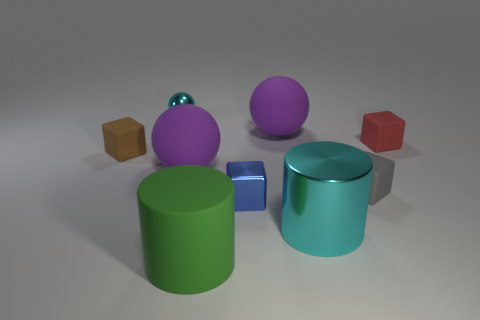What is the material of the tiny sphere that is the same color as the big metal cylinder?
Ensure brevity in your answer.  Metal. There is a metallic thing behind the small red rubber object; is its color the same as the big shiny cylinder?
Make the answer very short. Yes. There is another thing that is the same shape as the large metal thing; what is its size?
Ensure brevity in your answer.  Large. Is the number of rubber spheres behind the red block less than the number of rubber spheres?
Offer a terse response. Yes. There is another object that is the same shape as the big cyan shiny thing; what is its color?
Offer a terse response. Green. There is a sphere that is in front of the brown matte thing; is its size the same as the large cyan metal cylinder?
Give a very brief answer. Yes. How big is the cyan thing that is to the right of the small shiny object behind the brown matte cube?
Keep it short and to the point. Large. Is the big green cylinder made of the same material as the tiny blue object that is right of the small shiny sphere?
Ensure brevity in your answer.  No. Are there fewer cyan spheres on the right side of the gray cube than rubber spheres to the right of the metallic ball?
Your answer should be compact. Yes. The cylinder that is the same material as the small gray block is what color?
Your answer should be compact. Green. 